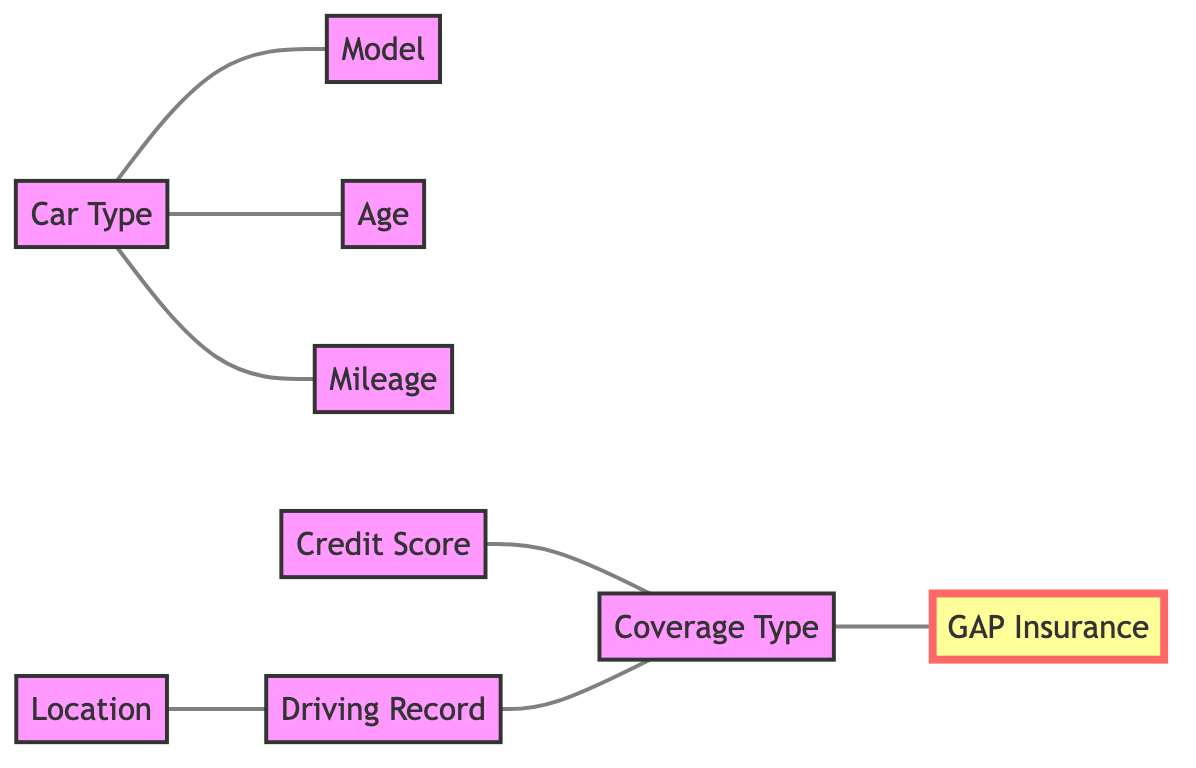What are the three main factors associated with Car Type? The diagram shows that Car Type is connected to three nodes: Model, Age, and Mileage. This means Car Type is influenced by these three factors.
Answer: Model, Age, Mileage Which node influences Driving Record? The diagram shows that Location is connected to Driving Record. This indicates that Location is a factor that influences Driving Record.
Answer: Location How many nodes are in this diagram? By counting the distinct nodes listed in the diagram, there are a total of 8 nodes: Car Type, Model, Age, Driving Record, Location, Coverage Type, Credit Score, Mileage, and GAP Insurance.
Answer: 8 What type of insurance is related to Coverage Type? The diagram indicates that Coverage Type is directly connected to GAP Insurance, meaning GAP Insurance is a type of insurance related to Coverage Type.
Answer: GAP Insurance What factors influence Coverage Type? Coverage Type is influenced by Driving Record and Credit Score, as these two nodes are directly connected to Coverage Type in the diagram.
Answer: Driving Record, Credit Score Which node connects to multiple others? Car Type connects to three other nodes: Model, Age, and Mileage, making it a node that has multiple connections in the diagram.
Answer: Car Type What is the relationship between Credit Score and Coverage Type? The diagram shows a direct connection between Credit Score and Coverage Type, indicating that Credit Score influences Coverage Type.
Answer: Credit Score influences Coverage Type Is there a relationship between Location and GAP Insurance? The diagram does not show a direct connection from Location to GAP Insurance. Instead, GAP Insurance is connected to Coverage Type, which is influenced by other factors, but not Location.
Answer: No 